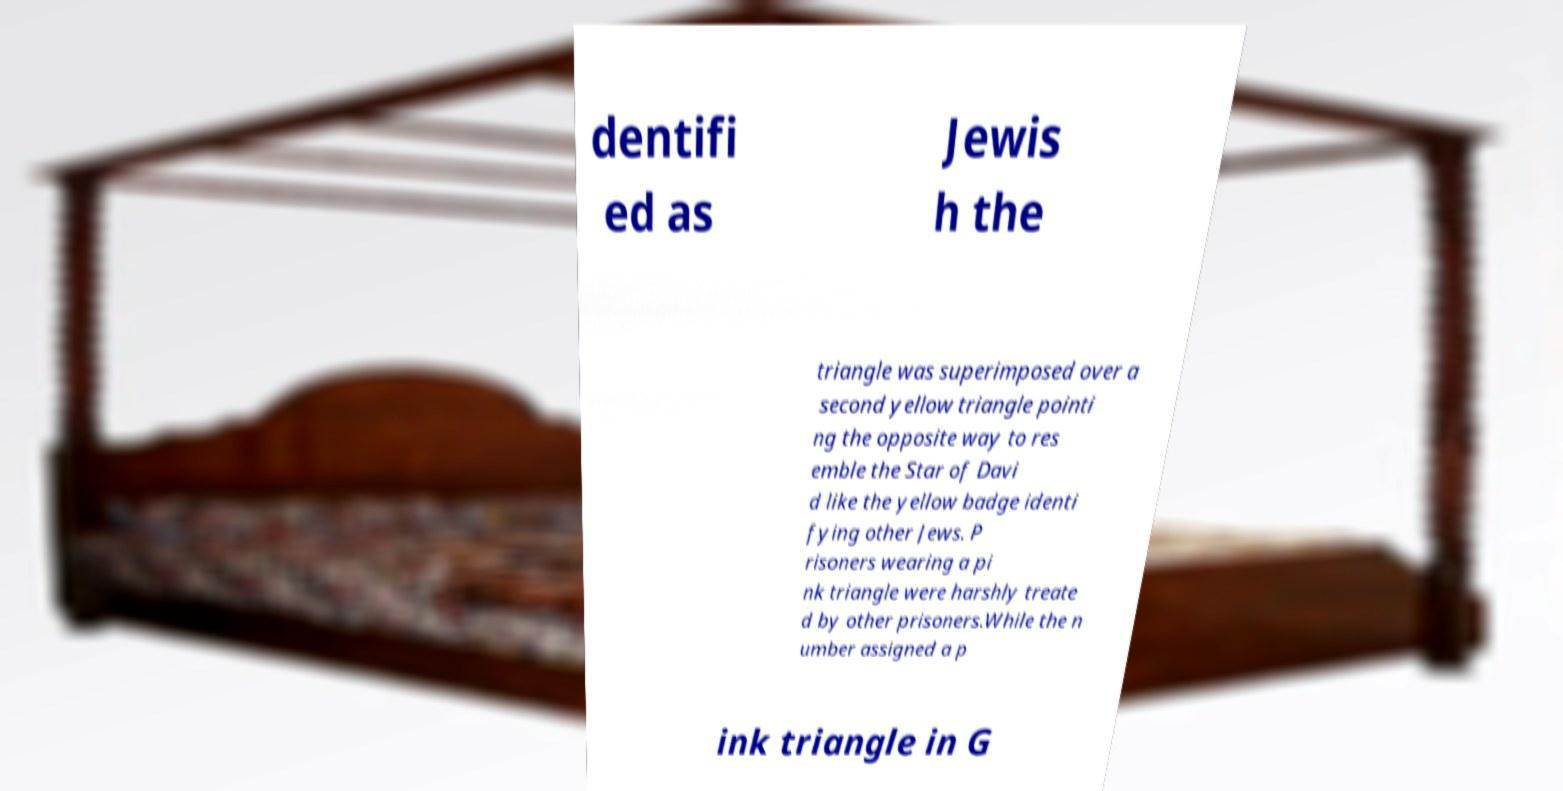Can you accurately transcribe the text from the provided image for me? dentifi ed as Jewis h the triangle was superimposed over a second yellow triangle pointi ng the opposite way to res emble the Star of Davi d like the yellow badge identi fying other Jews. P risoners wearing a pi nk triangle were harshly treate d by other prisoners.While the n umber assigned a p ink triangle in G 